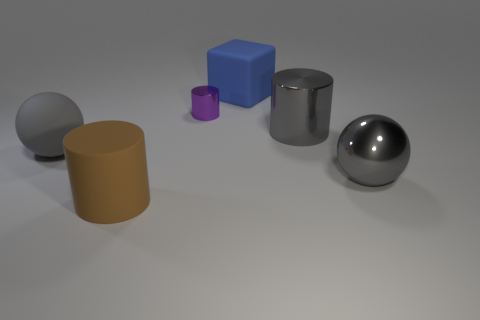There is another ball that is the same color as the metallic sphere; what is it made of?
Provide a short and direct response. Rubber. How big is the gray metallic object to the right of the cylinder that is on the right side of the big blue matte block?
Offer a very short reply. Large. Is there another large cyan block that has the same material as the large cube?
Make the answer very short. No. There is a cube that is the same size as the gray metallic sphere; what is its material?
Your answer should be very brief. Rubber. There is a shiny cylinder on the right side of the large blue cube; does it have the same color as the large cylinder on the left side of the small shiny object?
Your response must be concise. No. Are there any big metal things behind the gray object left of the blue thing?
Provide a succinct answer. Yes. Does the gray thing that is to the left of the brown rubber object have the same shape as the matte thing that is right of the brown object?
Provide a short and direct response. No. Do the thing in front of the big metallic ball and the sphere that is on the right side of the tiny purple shiny cylinder have the same material?
Provide a short and direct response. No. What is the material of the sphere that is on the left side of the big gray shiny cylinder that is behind the gray matte object?
Your answer should be compact. Rubber. What is the shape of the big matte thing that is in front of the gray sphere that is right of the gray thing that is left of the large blue block?
Your answer should be compact. Cylinder. 